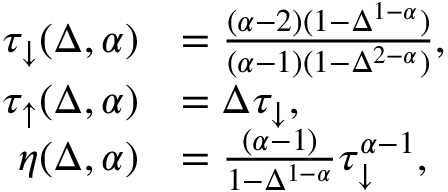<formula> <loc_0><loc_0><loc_500><loc_500>\begin{array} { r l } { \tau _ { \downarrow } ( \Delta , \alpha ) } & { = \frac { ( \alpha - 2 ) ( 1 - \Delta ^ { 1 - \alpha } ) } { ( \alpha - 1 ) ( 1 - \Delta ^ { 2 - \alpha } ) } , } \\ { \tau _ { \uparrow } ( \Delta , \alpha ) } & { = \Delta \tau _ { \downarrow } , } \\ { \eta ( \Delta , \alpha ) } & { = \frac { ( \alpha - 1 ) } { 1 - \Delta ^ { 1 - \alpha } } \tau _ { \downarrow } ^ { \alpha - 1 } , } \end{array}</formula> 